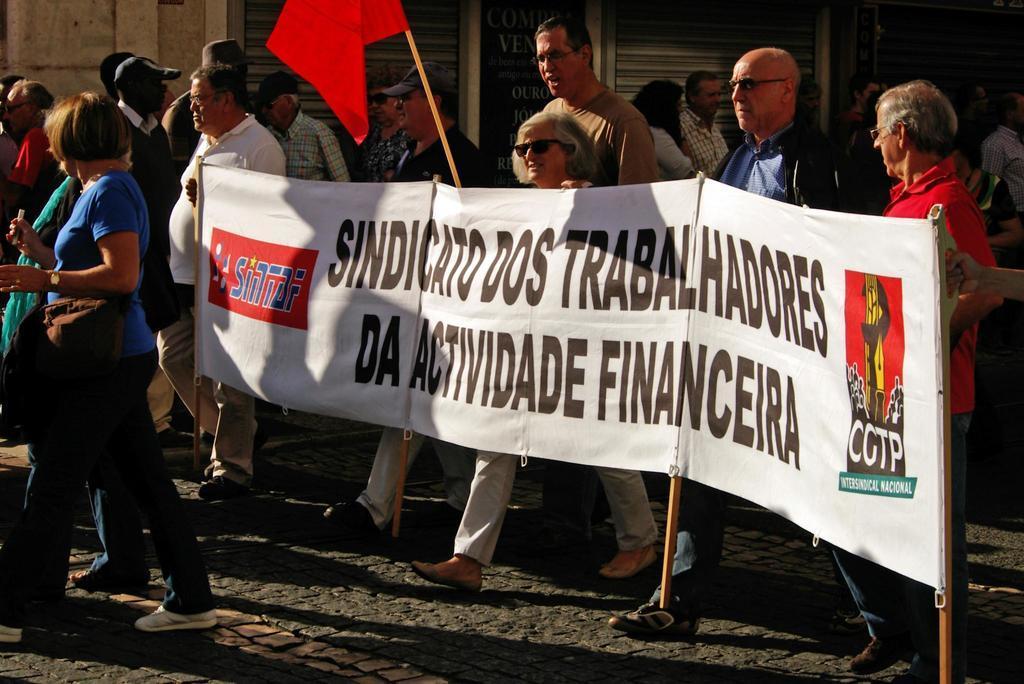Can you describe this image briefly? In this image, we can see some people walking and they are holding a white color poster, we can see a red color flag. 